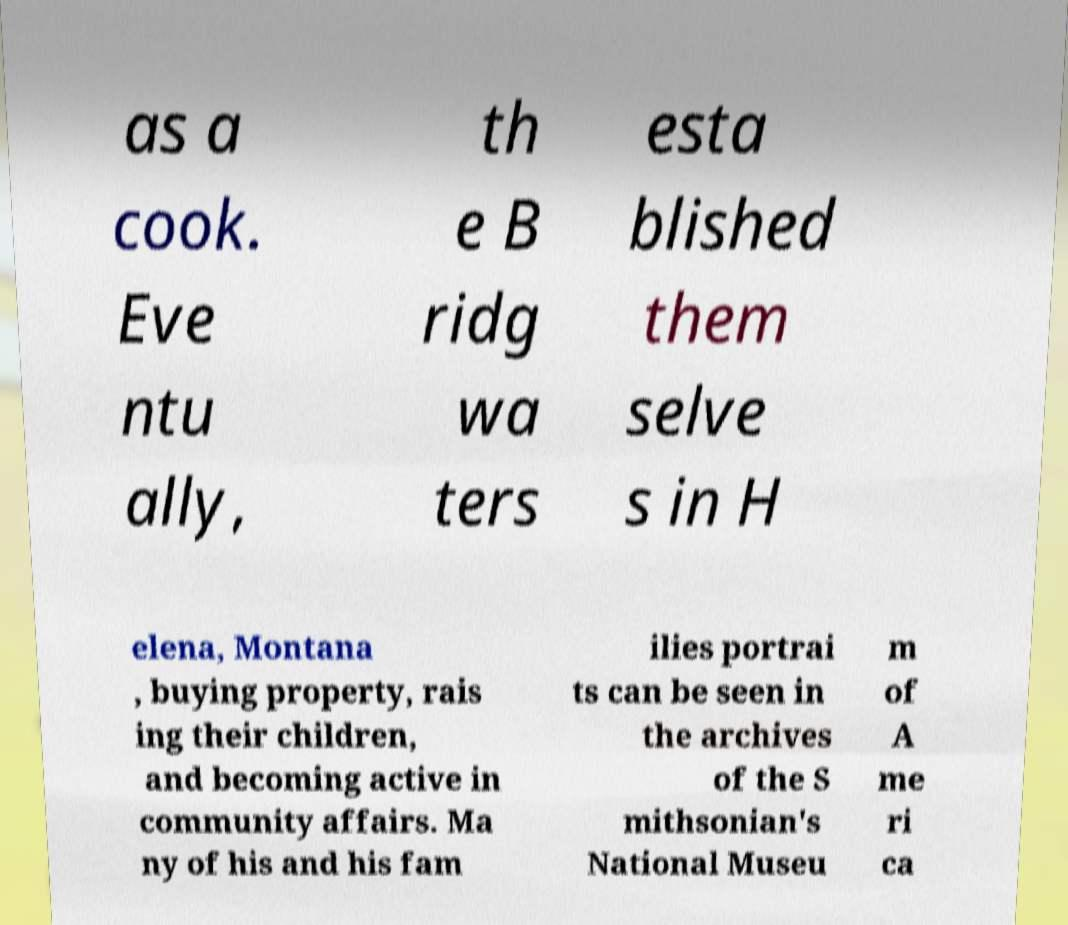Can you accurately transcribe the text from the provided image for me? as a cook. Eve ntu ally, th e B ridg wa ters esta blished them selve s in H elena, Montana , buying property, rais ing their children, and becoming active in community affairs. Ma ny of his and his fam ilies portrai ts can be seen in the archives of the S mithsonian's National Museu m of A me ri ca 